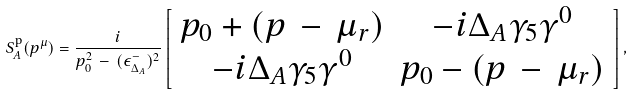<formula> <loc_0><loc_0><loc_500><loc_500>S ^ { \text {p} } _ { A } ( p ^ { \mu } ) = \frac { i } { p _ { 0 } ^ { 2 } \, - \, ( \epsilon ^ { - } _ { \Delta _ { A } } ) ^ { 2 } } \left [ \begin{array} { c c } p _ { 0 } + ( p \, - \, \mu _ { r } ) & - i \Delta _ { A } \gamma _ { 5 } \gamma ^ { 0 } \\ - i \Delta _ { A } \gamma _ { 5 } \gamma ^ { 0 } & p _ { 0 } - ( p \, - \, \mu _ { r } ) \end{array} \right ] ,</formula> 